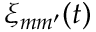Convert formula to latex. <formula><loc_0><loc_0><loc_500><loc_500>\xi _ { m m ^ { \prime } } ( t )</formula> 